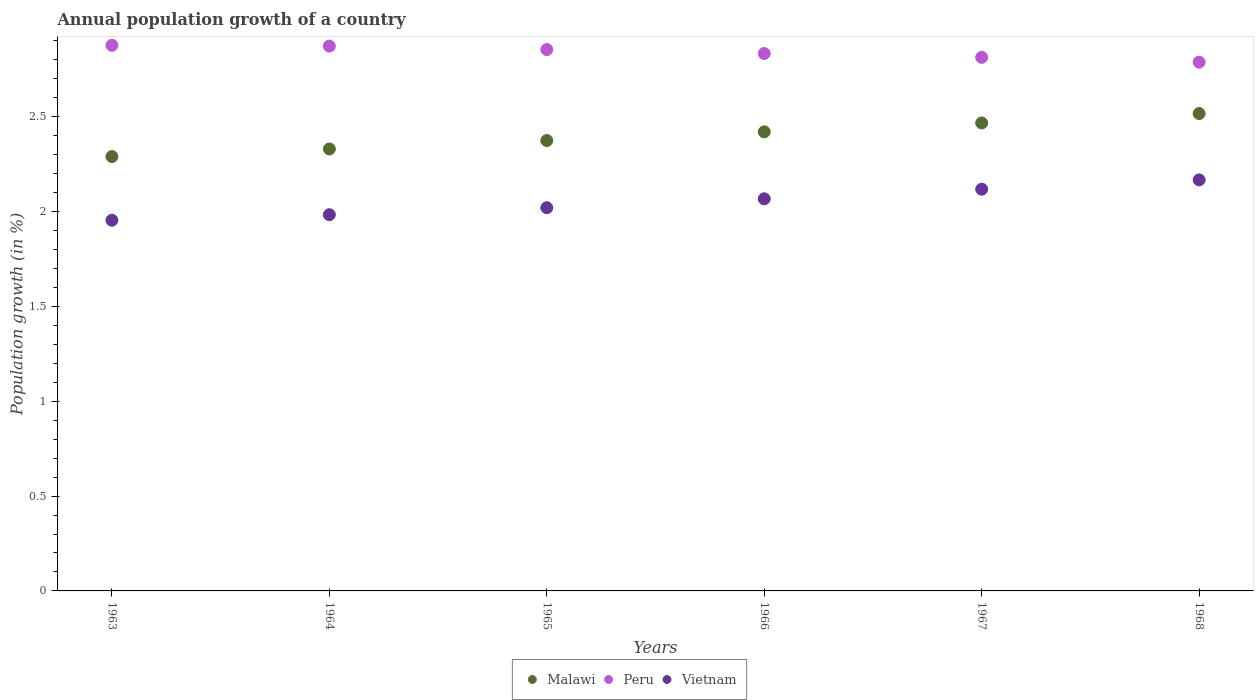How many different coloured dotlines are there?
Your response must be concise. 3. Is the number of dotlines equal to the number of legend labels?
Offer a very short reply. Yes. What is the annual population growth in Peru in 1964?
Keep it short and to the point. 2.87. Across all years, what is the maximum annual population growth in Peru?
Offer a very short reply. 2.88. Across all years, what is the minimum annual population growth in Malawi?
Offer a terse response. 2.29. In which year was the annual population growth in Malawi maximum?
Your answer should be very brief. 1968. In which year was the annual population growth in Peru minimum?
Offer a very short reply. 1968. What is the total annual population growth in Malawi in the graph?
Your answer should be very brief. 14.4. What is the difference between the annual population growth in Malawi in 1963 and that in 1965?
Your answer should be very brief. -0.08. What is the difference between the annual population growth in Peru in 1965 and the annual population growth in Vietnam in 1963?
Provide a short and direct response. 0.9. What is the average annual population growth in Malawi per year?
Ensure brevity in your answer.  2.4. In the year 1964, what is the difference between the annual population growth in Malawi and annual population growth in Peru?
Keep it short and to the point. -0.54. What is the ratio of the annual population growth in Vietnam in 1963 to that in 1967?
Give a very brief answer. 0.92. Is the difference between the annual population growth in Malawi in 1963 and 1965 greater than the difference between the annual population growth in Peru in 1963 and 1965?
Make the answer very short. No. What is the difference between the highest and the second highest annual population growth in Malawi?
Offer a very short reply. 0.05. What is the difference between the highest and the lowest annual population growth in Malawi?
Your response must be concise. 0.23. Is the sum of the annual population growth in Malawi in 1964 and 1967 greater than the maximum annual population growth in Peru across all years?
Your answer should be compact. Yes. Is the annual population growth in Peru strictly greater than the annual population growth in Malawi over the years?
Your response must be concise. Yes. Is the annual population growth in Peru strictly less than the annual population growth in Malawi over the years?
Make the answer very short. No. How many years are there in the graph?
Provide a short and direct response. 6. What is the difference between two consecutive major ticks on the Y-axis?
Provide a short and direct response. 0.5. Are the values on the major ticks of Y-axis written in scientific E-notation?
Offer a terse response. No. Does the graph contain any zero values?
Keep it short and to the point. No. Where does the legend appear in the graph?
Keep it short and to the point. Bottom center. What is the title of the graph?
Keep it short and to the point. Annual population growth of a country. Does "Colombia" appear as one of the legend labels in the graph?
Ensure brevity in your answer.  No. What is the label or title of the Y-axis?
Your answer should be compact. Population growth (in %). What is the Population growth (in %) in Malawi in 1963?
Your answer should be very brief. 2.29. What is the Population growth (in %) in Peru in 1963?
Make the answer very short. 2.88. What is the Population growth (in %) of Vietnam in 1963?
Provide a short and direct response. 1.95. What is the Population growth (in %) of Malawi in 1964?
Your response must be concise. 2.33. What is the Population growth (in %) of Peru in 1964?
Offer a very short reply. 2.87. What is the Population growth (in %) of Vietnam in 1964?
Give a very brief answer. 1.98. What is the Population growth (in %) of Malawi in 1965?
Provide a short and direct response. 2.37. What is the Population growth (in %) in Peru in 1965?
Offer a very short reply. 2.85. What is the Population growth (in %) in Vietnam in 1965?
Provide a short and direct response. 2.02. What is the Population growth (in %) in Malawi in 1966?
Make the answer very short. 2.42. What is the Population growth (in %) in Peru in 1966?
Offer a terse response. 2.83. What is the Population growth (in %) in Vietnam in 1966?
Your answer should be compact. 2.07. What is the Population growth (in %) of Malawi in 1967?
Provide a succinct answer. 2.47. What is the Population growth (in %) in Peru in 1967?
Provide a succinct answer. 2.81. What is the Population growth (in %) in Vietnam in 1967?
Give a very brief answer. 2.12. What is the Population growth (in %) in Malawi in 1968?
Give a very brief answer. 2.52. What is the Population growth (in %) in Peru in 1968?
Provide a succinct answer. 2.79. What is the Population growth (in %) in Vietnam in 1968?
Offer a terse response. 2.17. Across all years, what is the maximum Population growth (in %) of Malawi?
Keep it short and to the point. 2.52. Across all years, what is the maximum Population growth (in %) of Peru?
Ensure brevity in your answer.  2.88. Across all years, what is the maximum Population growth (in %) of Vietnam?
Offer a terse response. 2.17. Across all years, what is the minimum Population growth (in %) of Malawi?
Offer a very short reply. 2.29. Across all years, what is the minimum Population growth (in %) of Peru?
Your answer should be very brief. 2.79. Across all years, what is the minimum Population growth (in %) in Vietnam?
Make the answer very short. 1.95. What is the total Population growth (in %) of Malawi in the graph?
Your response must be concise. 14.4. What is the total Population growth (in %) in Peru in the graph?
Your answer should be very brief. 17.04. What is the total Population growth (in %) in Vietnam in the graph?
Your response must be concise. 12.31. What is the difference between the Population growth (in %) of Malawi in 1963 and that in 1964?
Ensure brevity in your answer.  -0.04. What is the difference between the Population growth (in %) of Peru in 1963 and that in 1964?
Your answer should be compact. 0. What is the difference between the Population growth (in %) of Vietnam in 1963 and that in 1964?
Offer a very short reply. -0.03. What is the difference between the Population growth (in %) in Malawi in 1963 and that in 1965?
Keep it short and to the point. -0.08. What is the difference between the Population growth (in %) in Peru in 1963 and that in 1965?
Your answer should be compact. 0.02. What is the difference between the Population growth (in %) in Vietnam in 1963 and that in 1965?
Give a very brief answer. -0.07. What is the difference between the Population growth (in %) in Malawi in 1963 and that in 1966?
Provide a short and direct response. -0.13. What is the difference between the Population growth (in %) in Peru in 1963 and that in 1966?
Offer a terse response. 0.04. What is the difference between the Population growth (in %) of Vietnam in 1963 and that in 1966?
Provide a succinct answer. -0.11. What is the difference between the Population growth (in %) in Malawi in 1963 and that in 1967?
Give a very brief answer. -0.18. What is the difference between the Population growth (in %) of Peru in 1963 and that in 1967?
Provide a succinct answer. 0.06. What is the difference between the Population growth (in %) of Vietnam in 1963 and that in 1967?
Provide a short and direct response. -0.16. What is the difference between the Population growth (in %) in Malawi in 1963 and that in 1968?
Your answer should be compact. -0.23. What is the difference between the Population growth (in %) in Peru in 1963 and that in 1968?
Your answer should be very brief. 0.09. What is the difference between the Population growth (in %) in Vietnam in 1963 and that in 1968?
Ensure brevity in your answer.  -0.21. What is the difference between the Population growth (in %) in Malawi in 1964 and that in 1965?
Provide a short and direct response. -0.04. What is the difference between the Population growth (in %) of Peru in 1964 and that in 1965?
Keep it short and to the point. 0.02. What is the difference between the Population growth (in %) of Vietnam in 1964 and that in 1965?
Your answer should be compact. -0.04. What is the difference between the Population growth (in %) in Malawi in 1964 and that in 1966?
Your answer should be very brief. -0.09. What is the difference between the Population growth (in %) in Peru in 1964 and that in 1966?
Ensure brevity in your answer.  0.04. What is the difference between the Population growth (in %) in Vietnam in 1964 and that in 1966?
Provide a short and direct response. -0.08. What is the difference between the Population growth (in %) of Malawi in 1964 and that in 1967?
Your response must be concise. -0.14. What is the difference between the Population growth (in %) in Peru in 1964 and that in 1967?
Provide a succinct answer. 0.06. What is the difference between the Population growth (in %) in Vietnam in 1964 and that in 1967?
Give a very brief answer. -0.13. What is the difference between the Population growth (in %) in Malawi in 1964 and that in 1968?
Your answer should be very brief. -0.19. What is the difference between the Population growth (in %) of Peru in 1964 and that in 1968?
Offer a terse response. 0.08. What is the difference between the Population growth (in %) in Vietnam in 1964 and that in 1968?
Offer a terse response. -0.18. What is the difference between the Population growth (in %) in Malawi in 1965 and that in 1966?
Give a very brief answer. -0.05. What is the difference between the Population growth (in %) in Peru in 1965 and that in 1966?
Offer a terse response. 0.02. What is the difference between the Population growth (in %) of Vietnam in 1965 and that in 1966?
Provide a short and direct response. -0.05. What is the difference between the Population growth (in %) in Malawi in 1965 and that in 1967?
Your response must be concise. -0.09. What is the difference between the Population growth (in %) in Peru in 1965 and that in 1967?
Your answer should be compact. 0.04. What is the difference between the Population growth (in %) in Vietnam in 1965 and that in 1967?
Your answer should be very brief. -0.1. What is the difference between the Population growth (in %) in Malawi in 1965 and that in 1968?
Offer a terse response. -0.14. What is the difference between the Population growth (in %) in Peru in 1965 and that in 1968?
Provide a short and direct response. 0.07. What is the difference between the Population growth (in %) of Vietnam in 1965 and that in 1968?
Your answer should be compact. -0.15. What is the difference between the Population growth (in %) in Malawi in 1966 and that in 1967?
Make the answer very short. -0.05. What is the difference between the Population growth (in %) in Peru in 1966 and that in 1967?
Make the answer very short. 0.02. What is the difference between the Population growth (in %) of Vietnam in 1966 and that in 1967?
Give a very brief answer. -0.05. What is the difference between the Population growth (in %) of Malawi in 1966 and that in 1968?
Give a very brief answer. -0.1. What is the difference between the Population growth (in %) in Peru in 1966 and that in 1968?
Keep it short and to the point. 0.05. What is the difference between the Population growth (in %) of Vietnam in 1966 and that in 1968?
Make the answer very short. -0.1. What is the difference between the Population growth (in %) in Malawi in 1967 and that in 1968?
Your answer should be very brief. -0.05. What is the difference between the Population growth (in %) of Peru in 1967 and that in 1968?
Ensure brevity in your answer.  0.03. What is the difference between the Population growth (in %) of Vietnam in 1967 and that in 1968?
Ensure brevity in your answer.  -0.05. What is the difference between the Population growth (in %) of Malawi in 1963 and the Population growth (in %) of Peru in 1964?
Keep it short and to the point. -0.58. What is the difference between the Population growth (in %) of Malawi in 1963 and the Population growth (in %) of Vietnam in 1964?
Ensure brevity in your answer.  0.31. What is the difference between the Population growth (in %) in Peru in 1963 and the Population growth (in %) in Vietnam in 1964?
Provide a succinct answer. 0.89. What is the difference between the Population growth (in %) of Malawi in 1963 and the Population growth (in %) of Peru in 1965?
Keep it short and to the point. -0.56. What is the difference between the Population growth (in %) in Malawi in 1963 and the Population growth (in %) in Vietnam in 1965?
Provide a succinct answer. 0.27. What is the difference between the Population growth (in %) in Peru in 1963 and the Population growth (in %) in Vietnam in 1965?
Give a very brief answer. 0.86. What is the difference between the Population growth (in %) of Malawi in 1963 and the Population growth (in %) of Peru in 1966?
Offer a terse response. -0.54. What is the difference between the Population growth (in %) in Malawi in 1963 and the Population growth (in %) in Vietnam in 1966?
Offer a very short reply. 0.22. What is the difference between the Population growth (in %) in Peru in 1963 and the Population growth (in %) in Vietnam in 1966?
Keep it short and to the point. 0.81. What is the difference between the Population growth (in %) of Malawi in 1963 and the Population growth (in %) of Peru in 1967?
Ensure brevity in your answer.  -0.52. What is the difference between the Population growth (in %) of Malawi in 1963 and the Population growth (in %) of Vietnam in 1967?
Make the answer very short. 0.17. What is the difference between the Population growth (in %) of Peru in 1963 and the Population growth (in %) of Vietnam in 1967?
Your answer should be compact. 0.76. What is the difference between the Population growth (in %) in Malawi in 1963 and the Population growth (in %) in Peru in 1968?
Offer a terse response. -0.5. What is the difference between the Population growth (in %) of Malawi in 1963 and the Population growth (in %) of Vietnam in 1968?
Give a very brief answer. 0.12. What is the difference between the Population growth (in %) of Peru in 1963 and the Population growth (in %) of Vietnam in 1968?
Keep it short and to the point. 0.71. What is the difference between the Population growth (in %) in Malawi in 1964 and the Population growth (in %) in Peru in 1965?
Offer a terse response. -0.52. What is the difference between the Population growth (in %) in Malawi in 1964 and the Population growth (in %) in Vietnam in 1965?
Make the answer very short. 0.31. What is the difference between the Population growth (in %) of Peru in 1964 and the Population growth (in %) of Vietnam in 1965?
Make the answer very short. 0.85. What is the difference between the Population growth (in %) of Malawi in 1964 and the Population growth (in %) of Peru in 1966?
Your answer should be very brief. -0.5. What is the difference between the Population growth (in %) of Malawi in 1964 and the Population growth (in %) of Vietnam in 1966?
Keep it short and to the point. 0.26. What is the difference between the Population growth (in %) in Peru in 1964 and the Population growth (in %) in Vietnam in 1966?
Give a very brief answer. 0.81. What is the difference between the Population growth (in %) in Malawi in 1964 and the Population growth (in %) in Peru in 1967?
Provide a succinct answer. -0.48. What is the difference between the Population growth (in %) in Malawi in 1964 and the Population growth (in %) in Vietnam in 1967?
Provide a short and direct response. 0.21. What is the difference between the Population growth (in %) of Peru in 1964 and the Population growth (in %) of Vietnam in 1967?
Your response must be concise. 0.75. What is the difference between the Population growth (in %) in Malawi in 1964 and the Population growth (in %) in Peru in 1968?
Ensure brevity in your answer.  -0.46. What is the difference between the Population growth (in %) of Malawi in 1964 and the Population growth (in %) of Vietnam in 1968?
Give a very brief answer. 0.16. What is the difference between the Population growth (in %) in Peru in 1964 and the Population growth (in %) in Vietnam in 1968?
Offer a terse response. 0.71. What is the difference between the Population growth (in %) of Malawi in 1965 and the Population growth (in %) of Peru in 1966?
Provide a succinct answer. -0.46. What is the difference between the Population growth (in %) in Malawi in 1965 and the Population growth (in %) in Vietnam in 1966?
Make the answer very short. 0.31. What is the difference between the Population growth (in %) of Peru in 1965 and the Population growth (in %) of Vietnam in 1966?
Ensure brevity in your answer.  0.79. What is the difference between the Population growth (in %) of Malawi in 1965 and the Population growth (in %) of Peru in 1967?
Your answer should be very brief. -0.44. What is the difference between the Population growth (in %) in Malawi in 1965 and the Population growth (in %) in Vietnam in 1967?
Give a very brief answer. 0.26. What is the difference between the Population growth (in %) in Peru in 1965 and the Population growth (in %) in Vietnam in 1967?
Provide a succinct answer. 0.74. What is the difference between the Population growth (in %) in Malawi in 1965 and the Population growth (in %) in Peru in 1968?
Give a very brief answer. -0.41. What is the difference between the Population growth (in %) of Malawi in 1965 and the Population growth (in %) of Vietnam in 1968?
Provide a short and direct response. 0.21. What is the difference between the Population growth (in %) of Peru in 1965 and the Population growth (in %) of Vietnam in 1968?
Offer a very short reply. 0.69. What is the difference between the Population growth (in %) in Malawi in 1966 and the Population growth (in %) in Peru in 1967?
Offer a terse response. -0.39. What is the difference between the Population growth (in %) of Malawi in 1966 and the Population growth (in %) of Vietnam in 1967?
Offer a very short reply. 0.3. What is the difference between the Population growth (in %) of Peru in 1966 and the Population growth (in %) of Vietnam in 1967?
Provide a succinct answer. 0.72. What is the difference between the Population growth (in %) of Malawi in 1966 and the Population growth (in %) of Peru in 1968?
Your answer should be compact. -0.37. What is the difference between the Population growth (in %) in Malawi in 1966 and the Population growth (in %) in Vietnam in 1968?
Offer a terse response. 0.25. What is the difference between the Population growth (in %) of Peru in 1966 and the Population growth (in %) of Vietnam in 1968?
Your response must be concise. 0.67. What is the difference between the Population growth (in %) in Malawi in 1967 and the Population growth (in %) in Peru in 1968?
Your response must be concise. -0.32. What is the difference between the Population growth (in %) of Malawi in 1967 and the Population growth (in %) of Vietnam in 1968?
Your answer should be compact. 0.3. What is the difference between the Population growth (in %) in Peru in 1967 and the Population growth (in %) in Vietnam in 1968?
Ensure brevity in your answer.  0.65. What is the average Population growth (in %) in Malawi per year?
Your answer should be compact. 2.4. What is the average Population growth (in %) in Peru per year?
Your answer should be compact. 2.84. What is the average Population growth (in %) in Vietnam per year?
Keep it short and to the point. 2.05. In the year 1963, what is the difference between the Population growth (in %) of Malawi and Population growth (in %) of Peru?
Provide a succinct answer. -0.59. In the year 1963, what is the difference between the Population growth (in %) in Malawi and Population growth (in %) in Vietnam?
Your answer should be compact. 0.34. In the year 1963, what is the difference between the Population growth (in %) of Peru and Population growth (in %) of Vietnam?
Offer a very short reply. 0.92. In the year 1964, what is the difference between the Population growth (in %) in Malawi and Population growth (in %) in Peru?
Offer a terse response. -0.54. In the year 1964, what is the difference between the Population growth (in %) of Malawi and Population growth (in %) of Vietnam?
Your answer should be compact. 0.35. In the year 1964, what is the difference between the Population growth (in %) in Peru and Population growth (in %) in Vietnam?
Ensure brevity in your answer.  0.89. In the year 1965, what is the difference between the Population growth (in %) in Malawi and Population growth (in %) in Peru?
Offer a terse response. -0.48. In the year 1965, what is the difference between the Population growth (in %) of Malawi and Population growth (in %) of Vietnam?
Make the answer very short. 0.35. In the year 1965, what is the difference between the Population growth (in %) in Peru and Population growth (in %) in Vietnam?
Provide a short and direct response. 0.83. In the year 1966, what is the difference between the Population growth (in %) of Malawi and Population growth (in %) of Peru?
Make the answer very short. -0.41. In the year 1966, what is the difference between the Population growth (in %) of Malawi and Population growth (in %) of Vietnam?
Offer a very short reply. 0.35. In the year 1966, what is the difference between the Population growth (in %) in Peru and Population growth (in %) in Vietnam?
Provide a short and direct response. 0.77. In the year 1967, what is the difference between the Population growth (in %) of Malawi and Population growth (in %) of Peru?
Your answer should be compact. -0.35. In the year 1967, what is the difference between the Population growth (in %) of Malawi and Population growth (in %) of Vietnam?
Give a very brief answer. 0.35. In the year 1967, what is the difference between the Population growth (in %) in Peru and Population growth (in %) in Vietnam?
Keep it short and to the point. 0.7. In the year 1968, what is the difference between the Population growth (in %) of Malawi and Population growth (in %) of Peru?
Your answer should be compact. -0.27. In the year 1968, what is the difference between the Population growth (in %) in Malawi and Population growth (in %) in Vietnam?
Your answer should be very brief. 0.35. In the year 1968, what is the difference between the Population growth (in %) of Peru and Population growth (in %) of Vietnam?
Your response must be concise. 0.62. What is the ratio of the Population growth (in %) of Malawi in 1963 to that in 1964?
Your answer should be very brief. 0.98. What is the ratio of the Population growth (in %) in Peru in 1963 to that in 1964?
Provide a short and direct response. 1. What is the ratio of the Population growth (in %) in Vietnam in 1963 to that in 1964?
Offer a terse response. 0.99. What is the ratio of the Population growth (in %) in Malawi in 1963 to that in 1965?
Offer a very short reply. 0.96. What is the ratio of the Population growth (in %) in Peru in 1963 to that in 1965?
Offer a terse response. 1.01. What is the ratio of the Population growth (in %) of Vietnam in 1963 to that in 1965?
Your answer should be compact. 0.97. What is the ratio of the Population growth (in %) in Malawi in 1963 to that in 1966?
Your response must be concise. 0.95. What is the ratio of the Population growth (in %) of Peru in 1963 to that in 1966?
Give a very brief answer. 1.02. What is the ratio of the Population growth (in %) in Vietnam in 1963 to that in 1966?
Your answer should be compact. 0.95. What is the ratio of the Population growth (in %) of Malawi in 1963 to that in 1967?
Offer a terse response. 0.93. What is the ratio of the Population growth (in %) in Peru in 1963 to that in 1967?
Provide a succinct answer. 1.02. What is the ratio of the Population growth (in %) of Vietnam in 1963 to that in 1967?
Your response must be concise. 0.92. What is the ratio of the Population growth (in %) in Malawi in 1963 to that in 1968?
Your response must be concise. 0.91. What is the ratio of the Population growth (in %) in Peru in 1963 to that in 1968?
Keep it short and to the point. 1.03. What is the ratio of the Population growth (in %) in Vietnam in 1963 to that in 1968?
Your response must be concise. 0.9. What is the ratio of the Population growth (in %) in Malawi in 1964 to that in 1965?
Provide a short and direct response. 0.98. What is the ratio of the Population growth (in %) in Peru in 1964 to that in 1965?
Offer a very short reply. 1.01. What is the ratio of the Population growth (in %) of Vietnam in 1964 to that in 1965?
Ensure brevity in your answer.  0.98. What is the ratio of the Population growth (in %) in Malawi in 1964 to that in 1966?
Your answer should be very brief. 0.96. What is the ratio of the Population growth (in %) of Peru in 1964 to that in 1966?
Give a very brief answer. 1.01. What is the ratio of the Population growth (in %) of Vietnam in 1964 to that in 1966?
Provide a succinct answer. 0.96. What is the ratio of the Population growth (in %) in Malawi in 1964 to that in 1967?
Provide a succinct answer. 0.94. What is the ratio of the Population growth (in %) of Peru in 1964 to that in 1967?
Provide a succinct answer. 1.02. What is the ratio of the Population growth (in %) of Vietnam in 1964 to that in 1967?
Offer a terse response. 0.94. What is the ratio of the Population growth (in %) in Malawi in 1964 to that in 1968?
Your response must be concise. 0.93. What is the ratio of the Population growth (in %) of Peru in 1964 to that in 1968?
Make the answer very short. 1.03. What is the ratio of the Population growth (in %) of Vietnam in 1964 to that in 1968?
Provide a succinct answer. 0.92. What is the ratio of the Population growth (in %) of Malawi in 1965 to that in 1966?
Give a very brief answer. 0.98. What is the ratio of the Population growth (in %) in Peru in 1965 to that in 1966?
Give a very brief answer. 1.01. What is the ratio of the Population growth (in %) of Vietnam in 1965 to that in 1966?
Offer a very short reply. 0.98. What is the ratio of the Population growth (in %) in Malawi in 1965 to that in 1967?
Ensure brevity in your answer.  0.96. What is the ratio of the Population growth (in %) of Peru in 1965 to that in 1967?
Provide a succinct answer. 1.01. What is the ratio of the Population growth (in %) of Vietnam in 1965 to that in 1967?
Offer a very short reply. 0.95. What is the ratio of the Population growth (in %) of Malawi in 1965 to that in 1968?
Provide a succinct answer. 0.94. What is the ratio of the Population growth (in %) in Peru in 1965 to that in 1968?
Offer a terse response. 1.02. What is the ratio of the Population growth (in %) of Vietnam in 1965 to that in 1968?
Provide a short and direct response. 0.93. What is the ratio of the Population growth (in %) in Malawi in 1966 to that in 1967?
Provide a short and direct response. 0.98. What is the ratio of the Population growth (in %) in Peru in 1966 to that in 1967?
Offer a very short reply. 1.01. What is the ratio of the Population growth (in %) of Vietnam in 1966 to that in 1967?
Make the answer very short. 0.98. What is the ratio of the Population growth (in %) in Malawi in 1966 to that in 1968?
Your response must be concise. 0.96. What is the ratio of the Population growth (in %) of Peru in 1966 to that in 1968?
Provide a short and direct response. 1.02. What is the ratio of the Population growth (in %) of Vietnam in 1966 to that in 1968?
Keep it short and to the point. 0.95. What is the ratio of the Population growth (in %) of Malawi in 1967 to that in 1968?
Offer a very short reply. 0.98. What is the ratio of the Population growth (in %) of Peru in 1967 to that in 1968?
Make the answer very short. 1.01. What is the ratio of the Population growth (in %) of Vietnam in 1967 to that in 1968?
Ensure brevity in your answer.  0.98. What is the difference between the highest and the second highest Population growth (in %) in Malawi?
Your response must be concise. 0.05. What is the difference between the highest and the second highest Population growth (in %) of Peru?
Give a very brief answer. 0. What is the difference between the highest and the second highest Population growth (in %) in Vietnam?
Provide a short and direct response. 0.05. What is the difference between the highest and the lowest Population growth (in %) of Malawi?
Your answer should be very brief. 0.23. What is the difference between the highest and the lowest Population growth (in %) in Peru?
Your answer should be compact. 0.09. What is the difference between the highest and the lowest Population growth (in %) of Vietnam?
Make the answer very short. 0.21. 